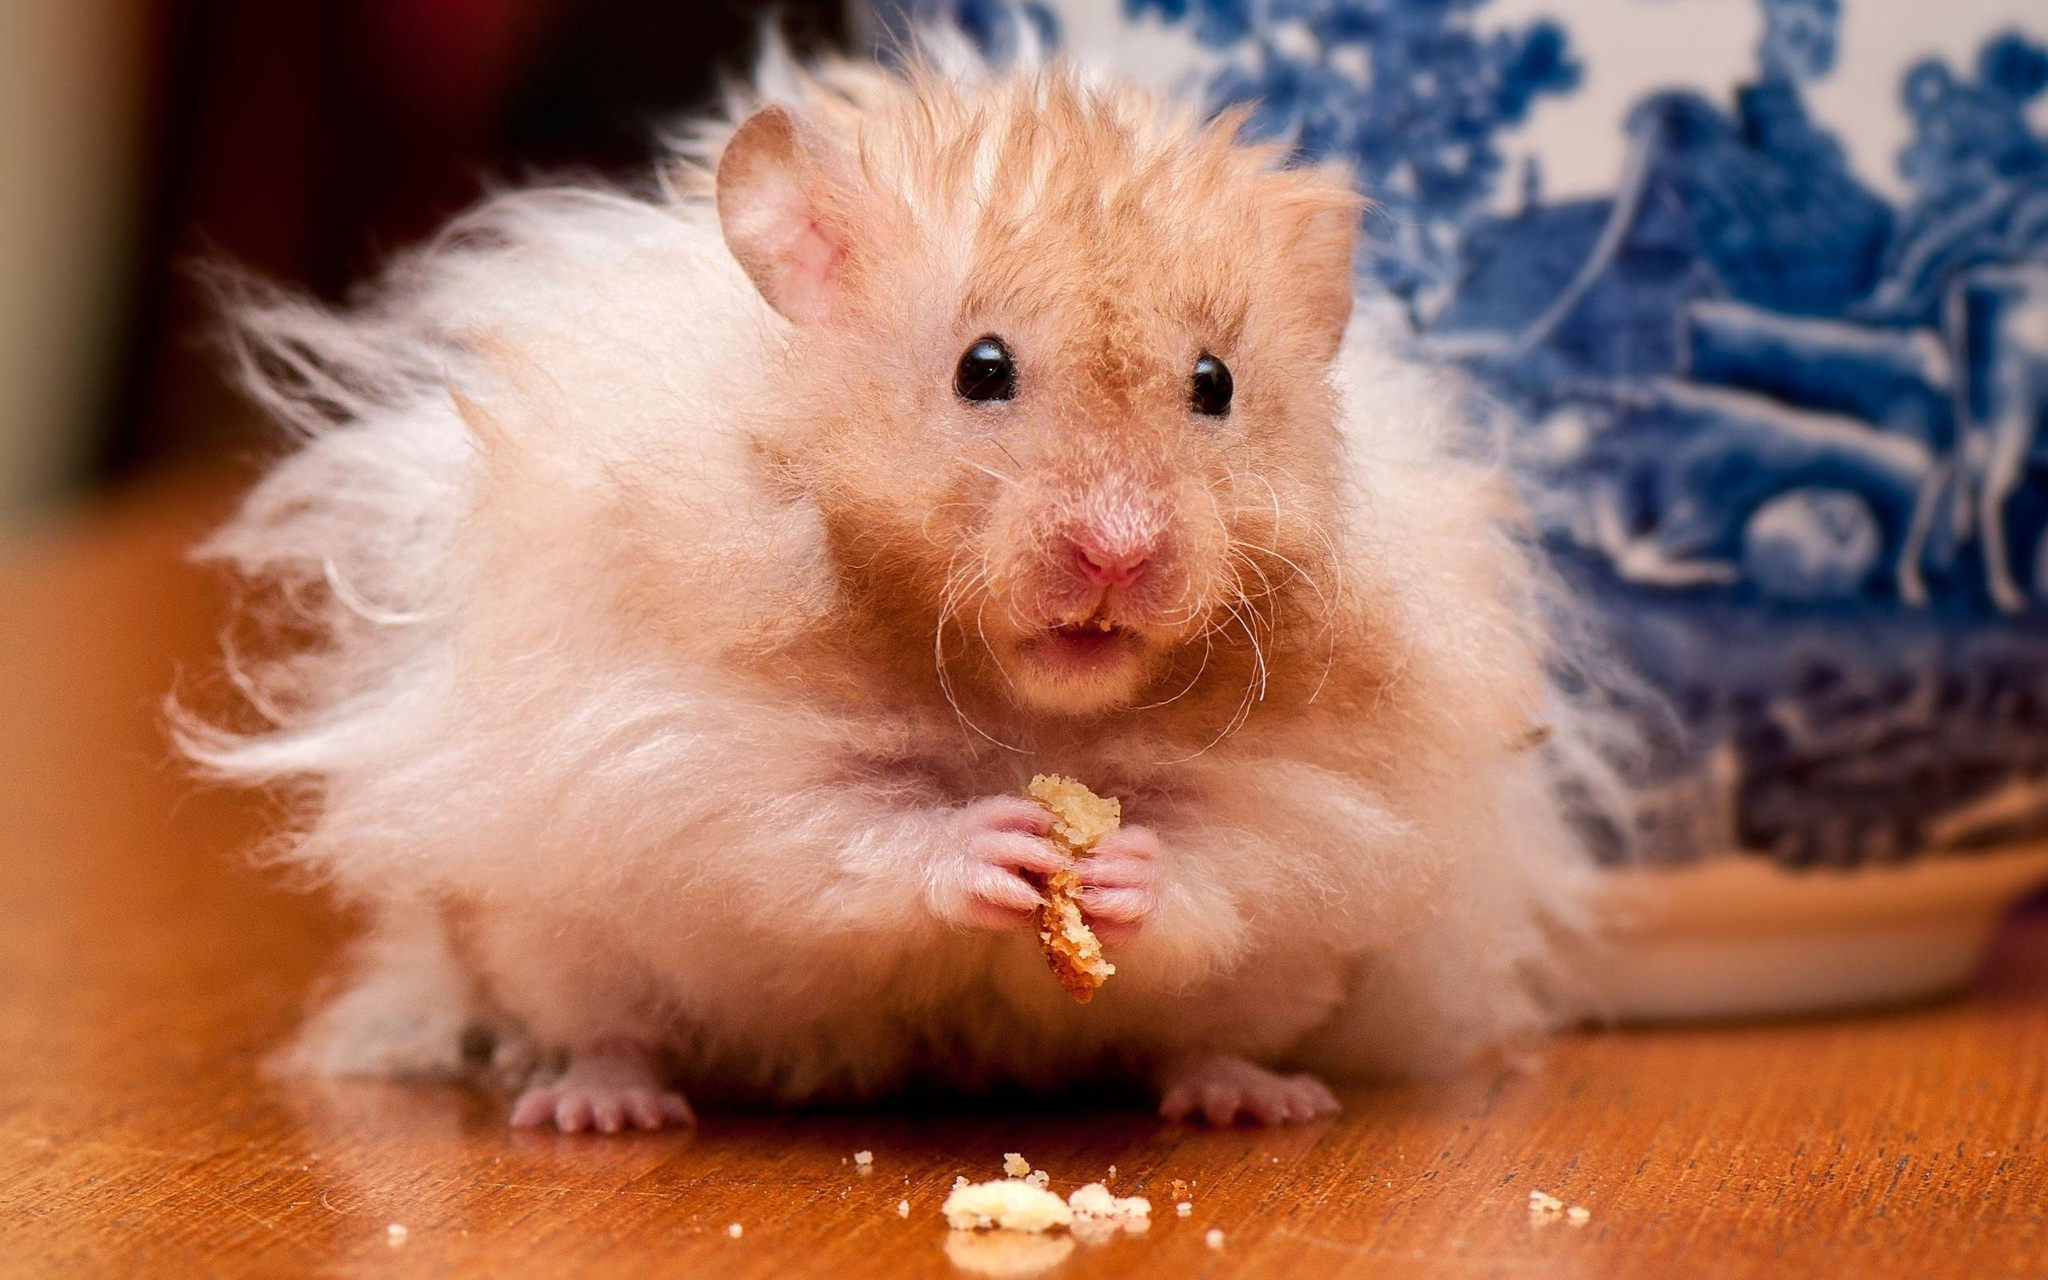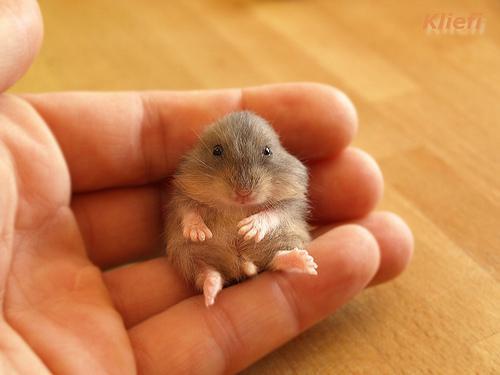The first image is the image on the left, the second image is the image on the right. For the images displayed, is the sentence "The rodent in one of the images is covered by a blanket." factually correct? Answer yes or no. No. The first image is the image on the left, the second image is the image on the right. Examine the images to the left and right. Is the description "The hamster in the right image is sleeping." accurate? Answer yes or no. No. 